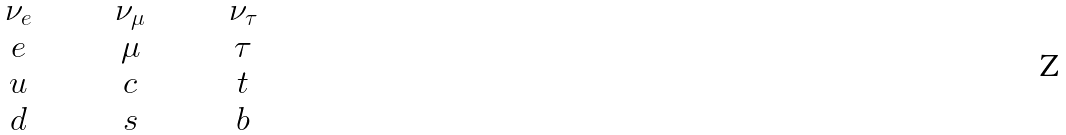Convert formula to latex. <formula><loc_0><loc_0><loc_500><loc_500>\begin{array} { c c c } \quad \nu _ { e } \quad & \quad \nu _ { \mu } \quad & \quad \nu _ { \tau } \quad \\ \quad e \quad & \quad \mu \quad & \quad \tau \quad \\ \quad u \quad & \quad c \quad & \quad t \quad \\ \quad d \quad & \quad s \quad & \quad b \quad \end{array}</formula> 